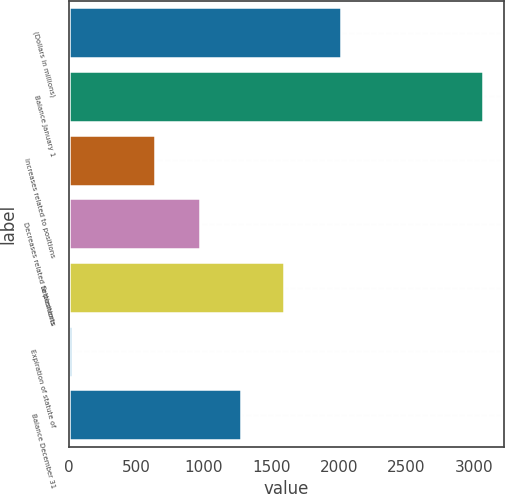Convert chart. <chart><loc_0><loc_0><loc_500><loc_500><bar_chart><fcel>(Dollars in millions)<fcel>Balance January 1<fcel>Increases related to positions<fcel>Decreases related to positions<fcel>Settlements<fcel>Expiration of statute of<fcel>Balance December 31<nl><fcel>2014<fcel>3068<fcel>635.2<fcel>973<fcel>1594<fcel>27<fcel>1277.1<nl></chart> 